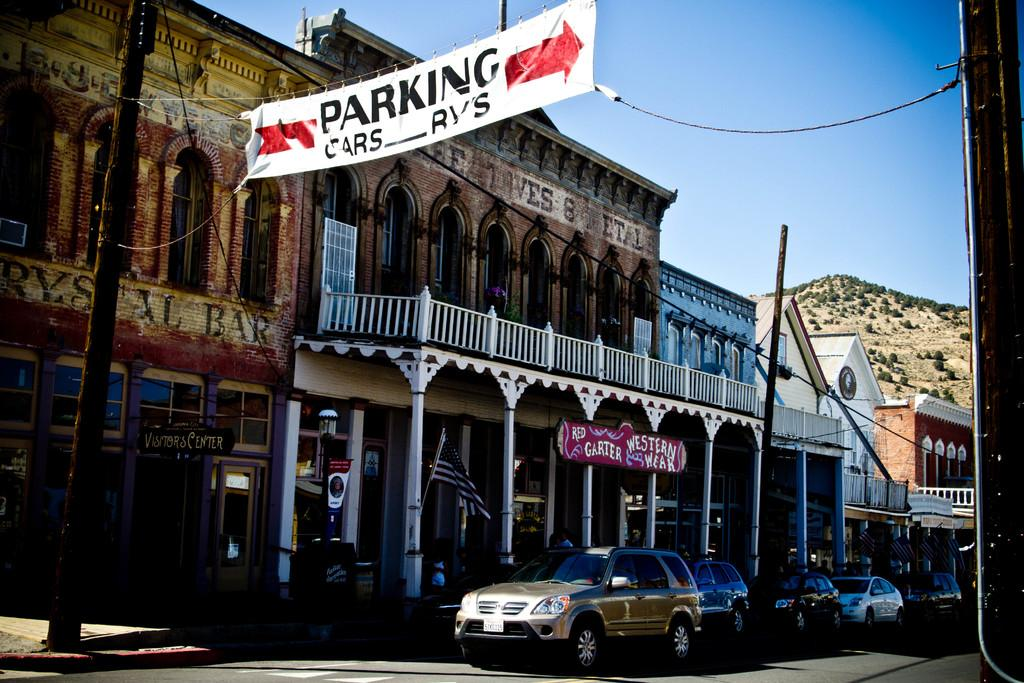Provide a one-sentence caption for the provided image. A banner promoting Red Garter Western Week is over a storefront. 